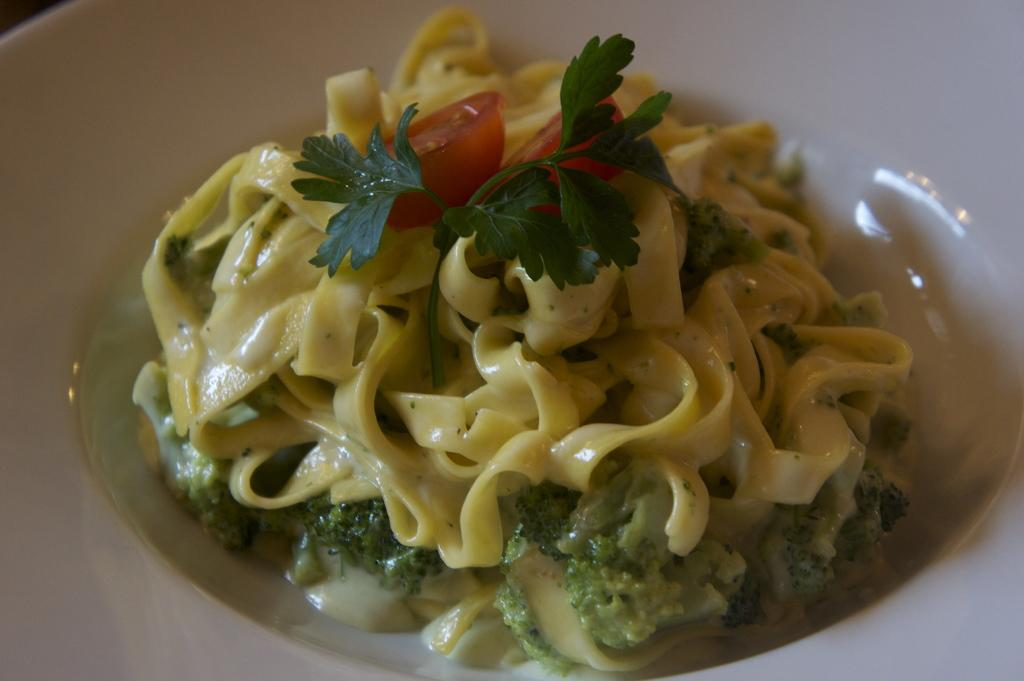What is in the bowl that is visible in the image? There is a bowl containing a kind of pasta in the image. What type of pasta is in the bowl? The pasta is made of spaghetti. What other ingredients are included in the spaghetti? The spaghetti contains slices of tomato, coriander leaves, broccoli, and other ingredients. What type of copper pot is used to cook the spaghetti in the image? There is no copper pot visible in the image, and the cooking process is not shown. 